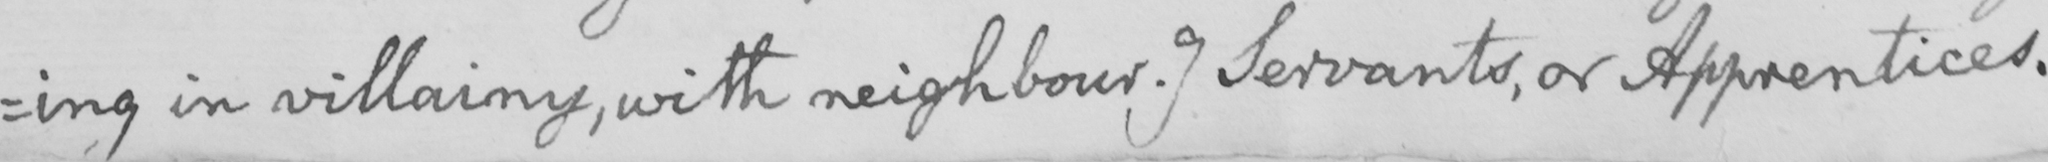Can you tell me what this handwritten text says? ing in villainy , with neighbour . ]  Servants , or Apprentices . 